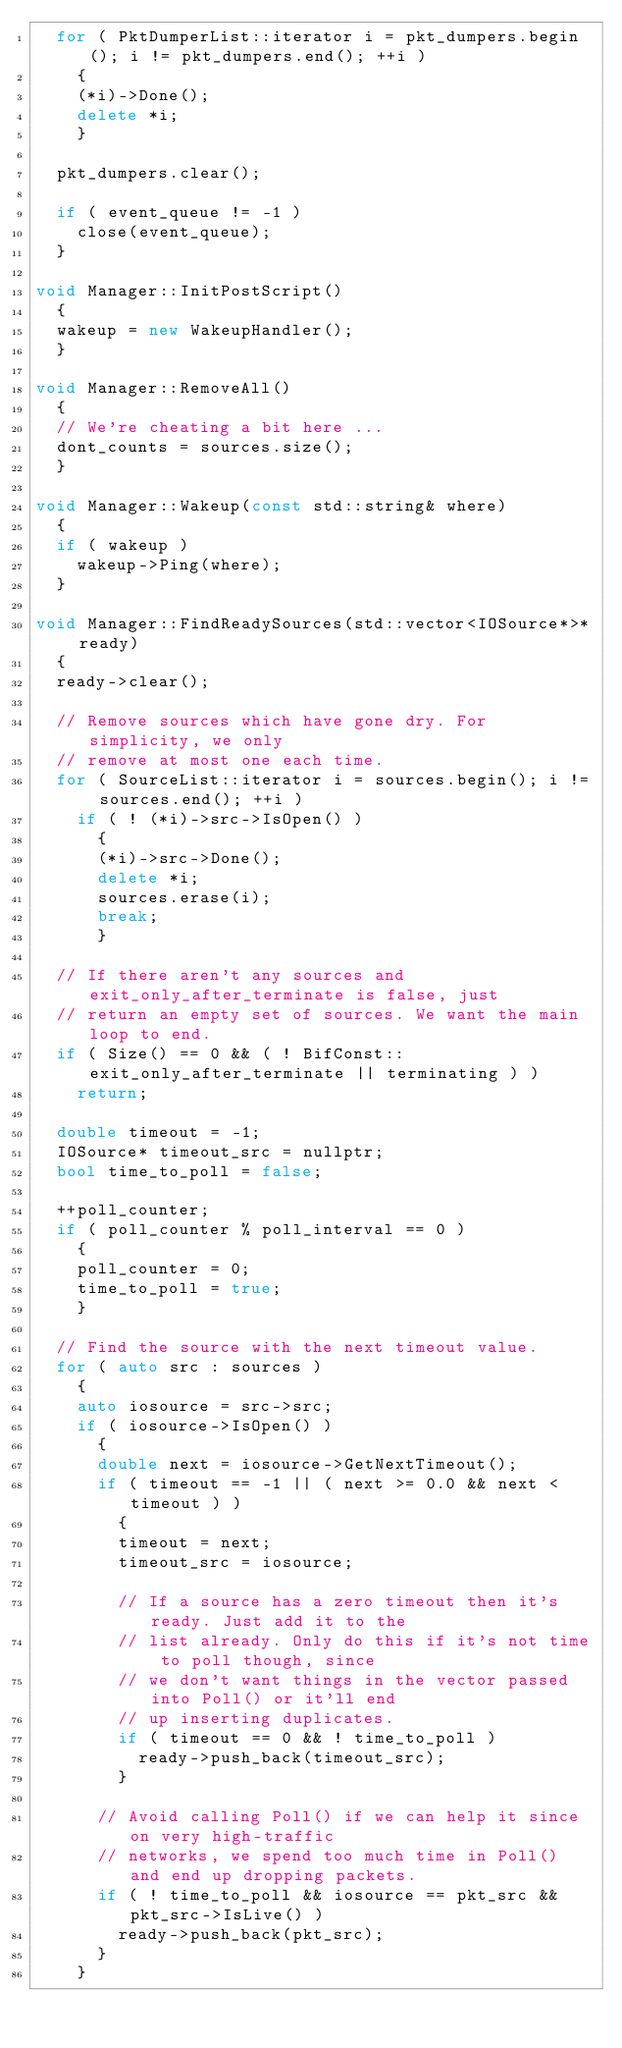<code> <loc_0><loc_0><loc_500><loc_500><_C++_>	for ( PktDumperList::iterator i = pkt_dumpers.begin(); i != pkt_dumpers.end(); ++i )
		{
		(*i)->Done();
		delete *i;
		}

	pkt_dumpers.clear();

	if ( event_queue != -1 )
		close(event_queue);
	}

void Manager::InitPostScript()
	{
	wakeup = new WakeupHandler();
	}

void Manager::RemoveAll()
	{
	// We're cheating a bit here ...
	dont_counts = sources.size();
	}

void Manager::Wakeup(const std::string& where)
	{
	if ( wakeup )
		wakeup->Ping(where);
	}

void Manager::FindReadySources(std::vector<IOSource*>* ready)
	{
	ready->clear();

	// Remove sources which have gone dry. For simplicity, we only
	// remove at most one each time.
	for ( SourceList::iterator i = sources.begin(); i != sources.end(); ++i )
		if ( ! (*i)->src->IsOpen() )
			{
			(*i)->src->Done();
			delete *i;
			sources.erase(i);
			break;
			}

	// If there aren't any sources and exit_only_after_terminate is false, just
	// return an empty set of sources. We want the main loop to end.
	if ( Size() == 0 && ( ! BifConst::exit_only_after_terminate || terminating ) )
		return;

	double timeout = -1;
	IOSource* timeout_src = nullptr;
	bool time_to_poll = false;

	++poll_counter;
	if ( poll_counter % poll_interval == 0 )
		{
		poll_counter = 0;
		time_to_poll = true;
		}

	// Find the source with the next timeout value.
	for ( auto src : sources )
		{
		auto iosource = src->src;
		if ( iosource->IsOpen() )
			{
			double next = iosource->GetNextTimeout();
			if ( timeout == -1 || ( next >= 0.0 && next < timeout ) )
				{
				timeout = next;
				timeout_src = iosource;

				// If a source has a zero timeout then it's ready. Just add it to the
				// list already. Only do this if it's not time to poll though, since
				// we don't want things in the vector passed into Poll() or it'll end
				// up inserting duplicates.
				if ( timeout == 0 && ! time_to_poll )
					ready->push_back(timeout_src);
				}

			// Avoid calling Poll() if we can help it since on very high-traffic
			// networks, we spend too much time in Poll() and end up dropping packets.
			if ( ! time_to_poll && iosource == pkt_src && pkt_src->IsLive() )
				ready->push_back(pkt_src);
			}
		}
</code> 